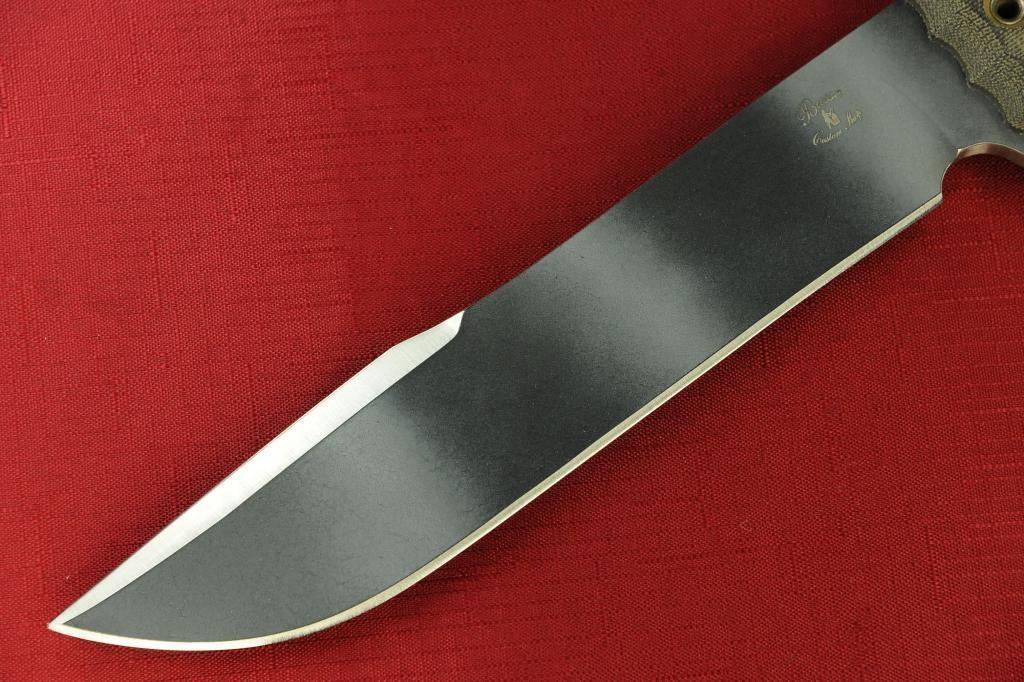What object can be seen in the image? There is a knife in the image. Where is the knife placed? The knife is placed on a red cloth. What type of knowledge is being transferred across the border in the image? There is no mention of knowledge or a border in the image; it only features a knife placed on a red cloth. 